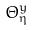Convert formula to latex. <formula><loc_0><loc_0><loc_500><loc_500>\Theta _ { \eta } ^ { y }</formula> 